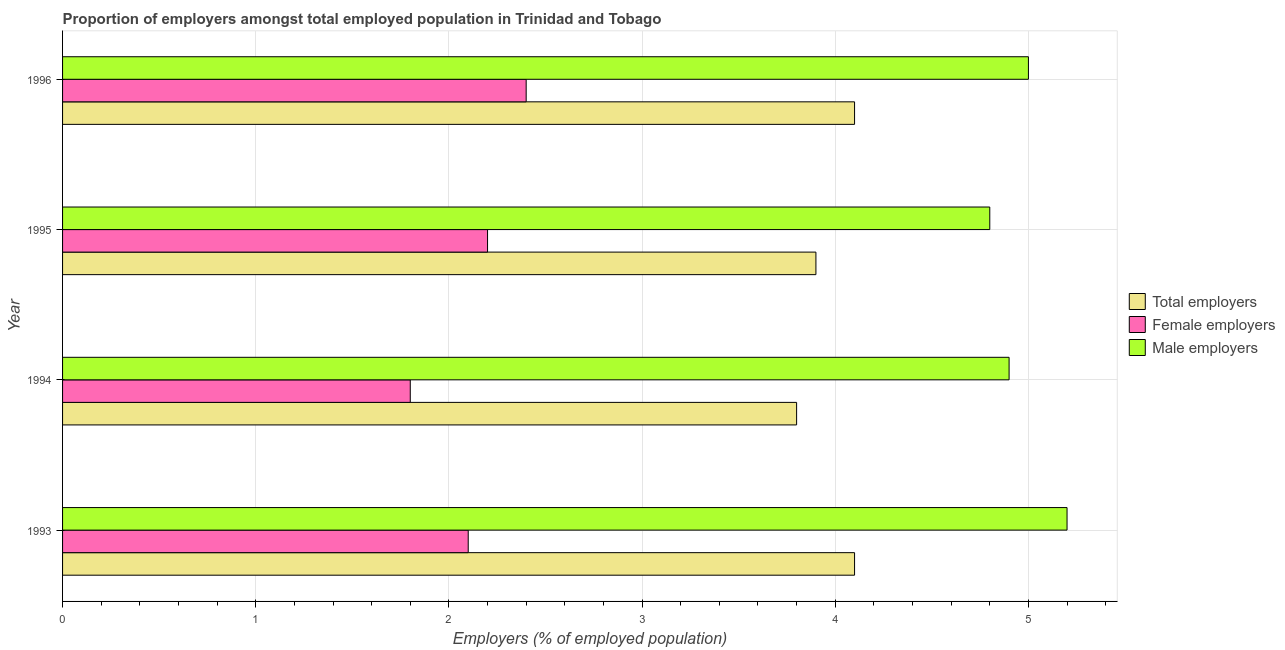How many groups of bars are there?
Make the answer very short. 4. Are the number of bars per tick equal to the number of legend labels?
Ensure brevity in your answer.  Yes. Are the number of bars on each tick of the Y-axis equal?
Your response must be concise. Yes. How many bars are there on the 1st tick from the bottom?
Your answer should be very brief. 3. In how many cases, is the number of bars for a given year not equal to the number of legend labels?
Ensure brevity in your answer.  0. What is the percentage of female employers in 1996?
Make the answer very short. 2.4. Across all years, what is the maximum percentage of male employers?
Ensure brevity in your answer.  5.2. Across all years, what is the minimum percentage of total employers?
Ensure brevity in your answer.  3.8. In which year was the percentage of female employers maximum?
Keep it short and to the point. 1996. What is the total percentage of male employers in the graph?
Your answer should be compact. 19.9. What is the difference between the percentage of male employers in 1993 and that in 1994?
Provide a short and direct response. 0.3. What is the difference between the percentage of total employers in 1995 and the percentage of male employers in 1996?
Provide a succinct answer. -1.1. What is the average percentage of female employers per year?
Give a very brief answer. 2.12. In the year 1995, what is the difference between the percentage of total employers and percentage of female employers?
Your response must be concise. 1.7. Is the percentage of male employers in 1993 less than that in 1994?
Your response must be concise. No. In how many years, is the percentage of male employers greater than the average percentage of male employers taken over all years?
Your answer should be compact. 2. Is the sum of the percentage of total employers in 1995 and 1996 greater than the maximum percentage of male employers across all years?
Give a very brief answer. Yes. What does the 3rd bar from the top in 1994 represents?
Keep it short and to the point. Total employers. What does the 1st bar from the bottom in 1996 represents?
Keep it short and to the point. Total employers. Is it the case that in every year, the sum of the percentage of total employers and percentage of female employers is greater than the percentage of male employers?
Offer a very short reply. Yes. How many bars are there?
Offer a very short reply. 12. Are all the bars in the graph horizontal?
Make the answer very short. Yes. How many years are there in the graph?
Your response must be concise. 4. Does the graph contain any zero values?
Your response must be concise. No. Does the graph contain grids?
Offer a very short reply. Yes. Where does the legend appear in the graph?
Offer a terse response. Center right. How many legend labels are there?
Your answer should be compact. 3. What is the title of the graph?
Your answer should be very brief. Proportion of employers amongst total employed population in Trinidad and Tobago. Does "Infant(male)" appear as one of the legend labels in the graph?
Provide a succinct answer. No. What is the label or title of the X-axis?
Give a very brief answer. Employers (% of employed population). What is the label or title of the Y-axis?
Give a very brief answer. Year. What is the Employers (% of employed population) in Total employers in 1993?
Your answer should be very brief. 4.1. What is the Employers (% of employed population) of Female employers in 1993?
Offer a very short reply. 2.1. What is the Employers (% of employed population) in Male employers in 1993?
Offer a very short reply. 5.2. What is the Employers (% of employed population) in Total employers in 1994?
Make the answer very short. 3.8. What is the Employers (% of employed population) of Female employers in 1994?
Keep it short and to the point. 1.8. What is the Employers (% of employed population) of Male employers in 1994?
Provide a succinct answer. 4.9. What is the Employers (% of employed population) of Total employers in 1995?
Your response must be concise. 3.9. What is the Employers (% of employed population) of Female employers in 1995?
Make the answer very short. 2.2. What is the Employers (% of employed population) of Male employers in 1995?
Your answer should be very brief. 4.8. What is the Employers (% of employed population) in Total employers in 1996?
Ensure brevity in your answer.  4.1. What is the Employers (% of employed population) of Female employers in 1996?
Your response must be concise. 2.4. What is the Employers (% of employed population) of Male employers in 1996?
Your response must be concise. 5. Across all years, what is the maximum Employers (% of employed population) in Total employers?
Your response must be concise. 4.1. Across all years, what is the maximum Employers (% of employed population) of Female employers?
Offer a very short reply. 2.4. Across all years, what is the maximum Employers (% of employed population) in Male employers?
Give a very brief answer. 5.2. Across all years, what is the minimum Employers (% of employed population) in Total employers?
Your answer should be very brief. 3.8. Across all years, what is the minimum Employers (% of employed population) of Female employers?
Your answer should be very brief. 1.8. Across all years, what is the minimum Employers (% of employed population) in Male employers?
Ensure brevity in your answer.  4.8. What is the total Employers (% of employed population) in Total employers in the graph?
Provide a succinct answer. 15.9. What is the difference between the Employers (% of employed population) of Female employers in 1993 and that in 1994?
Your answer should be compact. 0.3. What is the difference between the Employers (% of employed population) of Male employers in 1993 and that in 1994?
Your answer should be very brief. 0.3. What is the difference between the Employers (% of employed population) in Total employers in 1993 and that in 1995?
Ensure brevity in your answer.  0.2. What is the difference between the Employers (% of employed population) in Female employers in 1993 and that in 1995?
Your answer should be compact. -0.1. What is the difference between the Employers (% of employed population) in Male employers in 1993 and that in 1995?
Your answer should be compact. 0.4. What is the difference between the Employers (% of employed population) of Male employers in 1993 and that in 1996?
Keep it short and to the point. 0.2. What is the difference between the Employers (% of employed population) in Total employers in 1994 and that in 1995?
Provide a succinct answer. -0.1. What is the difference between the Employers (% of employed population) of Total employers in 1994 and that in 1996?
Make the answer very short. -0.3. What is the difference between the Employers (% of employed population) of Male employers in 1994 and that in 1996?
Your response must be concise. -0.1. What is the difference between the Employers (% of employed population) in Total employers in 1993 and the Employers (% of employed population) in Female employers in 1994?
Your answer should be compact. 2.3. What is the difference between the Employers (% of employed population) of Female employers in 1993 and the Employers (% of employed population) of Male employers in 1994?
Your answer should be very brief. -2.8. What is the difference between the Employers (% of employed population) of Total employers in 1993 and the Employers (% of employed population) of Male employers in 1995?
Provide a succinct answer. -0.7. What is the difference between the Employers (% of employed population) in Total employers in 1993 and the Employers (% of employed population) in Male employers in 1996?
Provide a short and direct response. -0.9. What is the difference between the Employers (% of employed population) in Total employers in 1994 and the Employers (% of employed population) in Female employers in 1996?
Give a very brief answer. 1.4. What is the difference between the Employers (% of employed population) in Female employers in 1995 and the Employers (% of employed population) in Male employers in 1996?
Your response must be concise. -2.8. What is the average Employers (% of employed population) in Total employers per year?
Give a very brief answer. 3.98. What is the average Employers (% of employed population) of Female employers per year?
Your response must be concise. 2.12. What is the average Employers (% of employed population) of Male employers per year?
Your answer should be very brief. 4.97. In the year 1993, what is the difference between the Employers (% of employed population) in Total employers and Employers (% of employed population) in Female employers?
Keep it short and to the point. 2. In the year 1993, what is the difference between the Employers (% of employed population) in Female employers and Employers (% of employed population) in Male employers?
Give a very brief answer. -3.1. In the year 1994, what is the difference between the Employers (% of employed population) in Total employers and Employers (% of employed population) in Female employers?
Give a very brief answer. 2. In the year 1994, what is the difference between the Employers (% of employed population) of Total employers and Employers (% of employed population) of Male employers?
Give a very brief answer. -1.1. In the year 1995, what is the difference between the Employers (% of employed population) of Total employers and Employers (% of employed population) of Female employers?
Provide a short and direct response. 1.7. In the year 1995, what is the difference between the Employers (% of employed population) in Total employers and Employers (% of employed population) in Male employers?
Give a very brief answer. -0.9. In the year 1996, what is the difference between the Employers (% of employed population) of Total employers and Employers (% of employed population) of Female employers?
Your answer should be compact. 1.7. In the year 1996, what is the difference between the Employers (% of employed population) of Female employers and Employers (% of employed population) of Male employers?
Provide a succinct answer. -2.6. What is the ratio of the Employers (% of employed population) in Total employers in 1993 to that in 1994?
Your answer should be compact. 1.08. What is the ratio of the Employers (% of employed population) of Female employers in 1993 to that in 1994?
Keep it short and to the point. 1.17. What is the ratio of the Employers (% of employed population) in Male employers in 1993 to that in 1994?
Offer a very short reply. 1.06. What is the ratio of the Employers (% of employed population) in Total employers in 1993 to that in 1995?
Give a very brief answer. 1.05. What is the ratio of the Employers (% of employed population) in Female employers in 1993 to that in 1995?
Give a very brief answer. 0.95. What is the ratio of the Employers (% of employed population) of Total employers in 1993 to that in 1996?
Give a very brief answer. 1. What is the ratio of the Employers (% of employed population) in Total employers in 1994 to that in 1995?
Offer a terse response. 0.97. What is the ratio of the Employers (% of employed population) in Female employers in 1994 to that in 1995?
Keep it short and to the point. 0.82. What is the ratio of the Employers (% of employed population) in Male employers in 1994 to that in 1995?
Provide a succinct answer. 1.02. What is the ratio of the Employers (% of employed population) of Total employers in 1994 to that in 1996?
Offer a terse response. 0.93. What is the ratio of the Employers (% of employed population) of Male employers in 1994 to that in 1996?
Give a very brief answer. 0.98. What is the ratio of the Employers (% of employed population) in Total employers in 1995 to that in 1996?
Provide a short and direct response. 0.95. What is the ratio of the Employers (% of employed population) of Male employers in 1995 to that in 1996?
Keep it short and to the point. 0.96. What is the difference between the highest and the second highest Employers (% of employed population) of Male employers?
Your response must be concise. 0.2. 